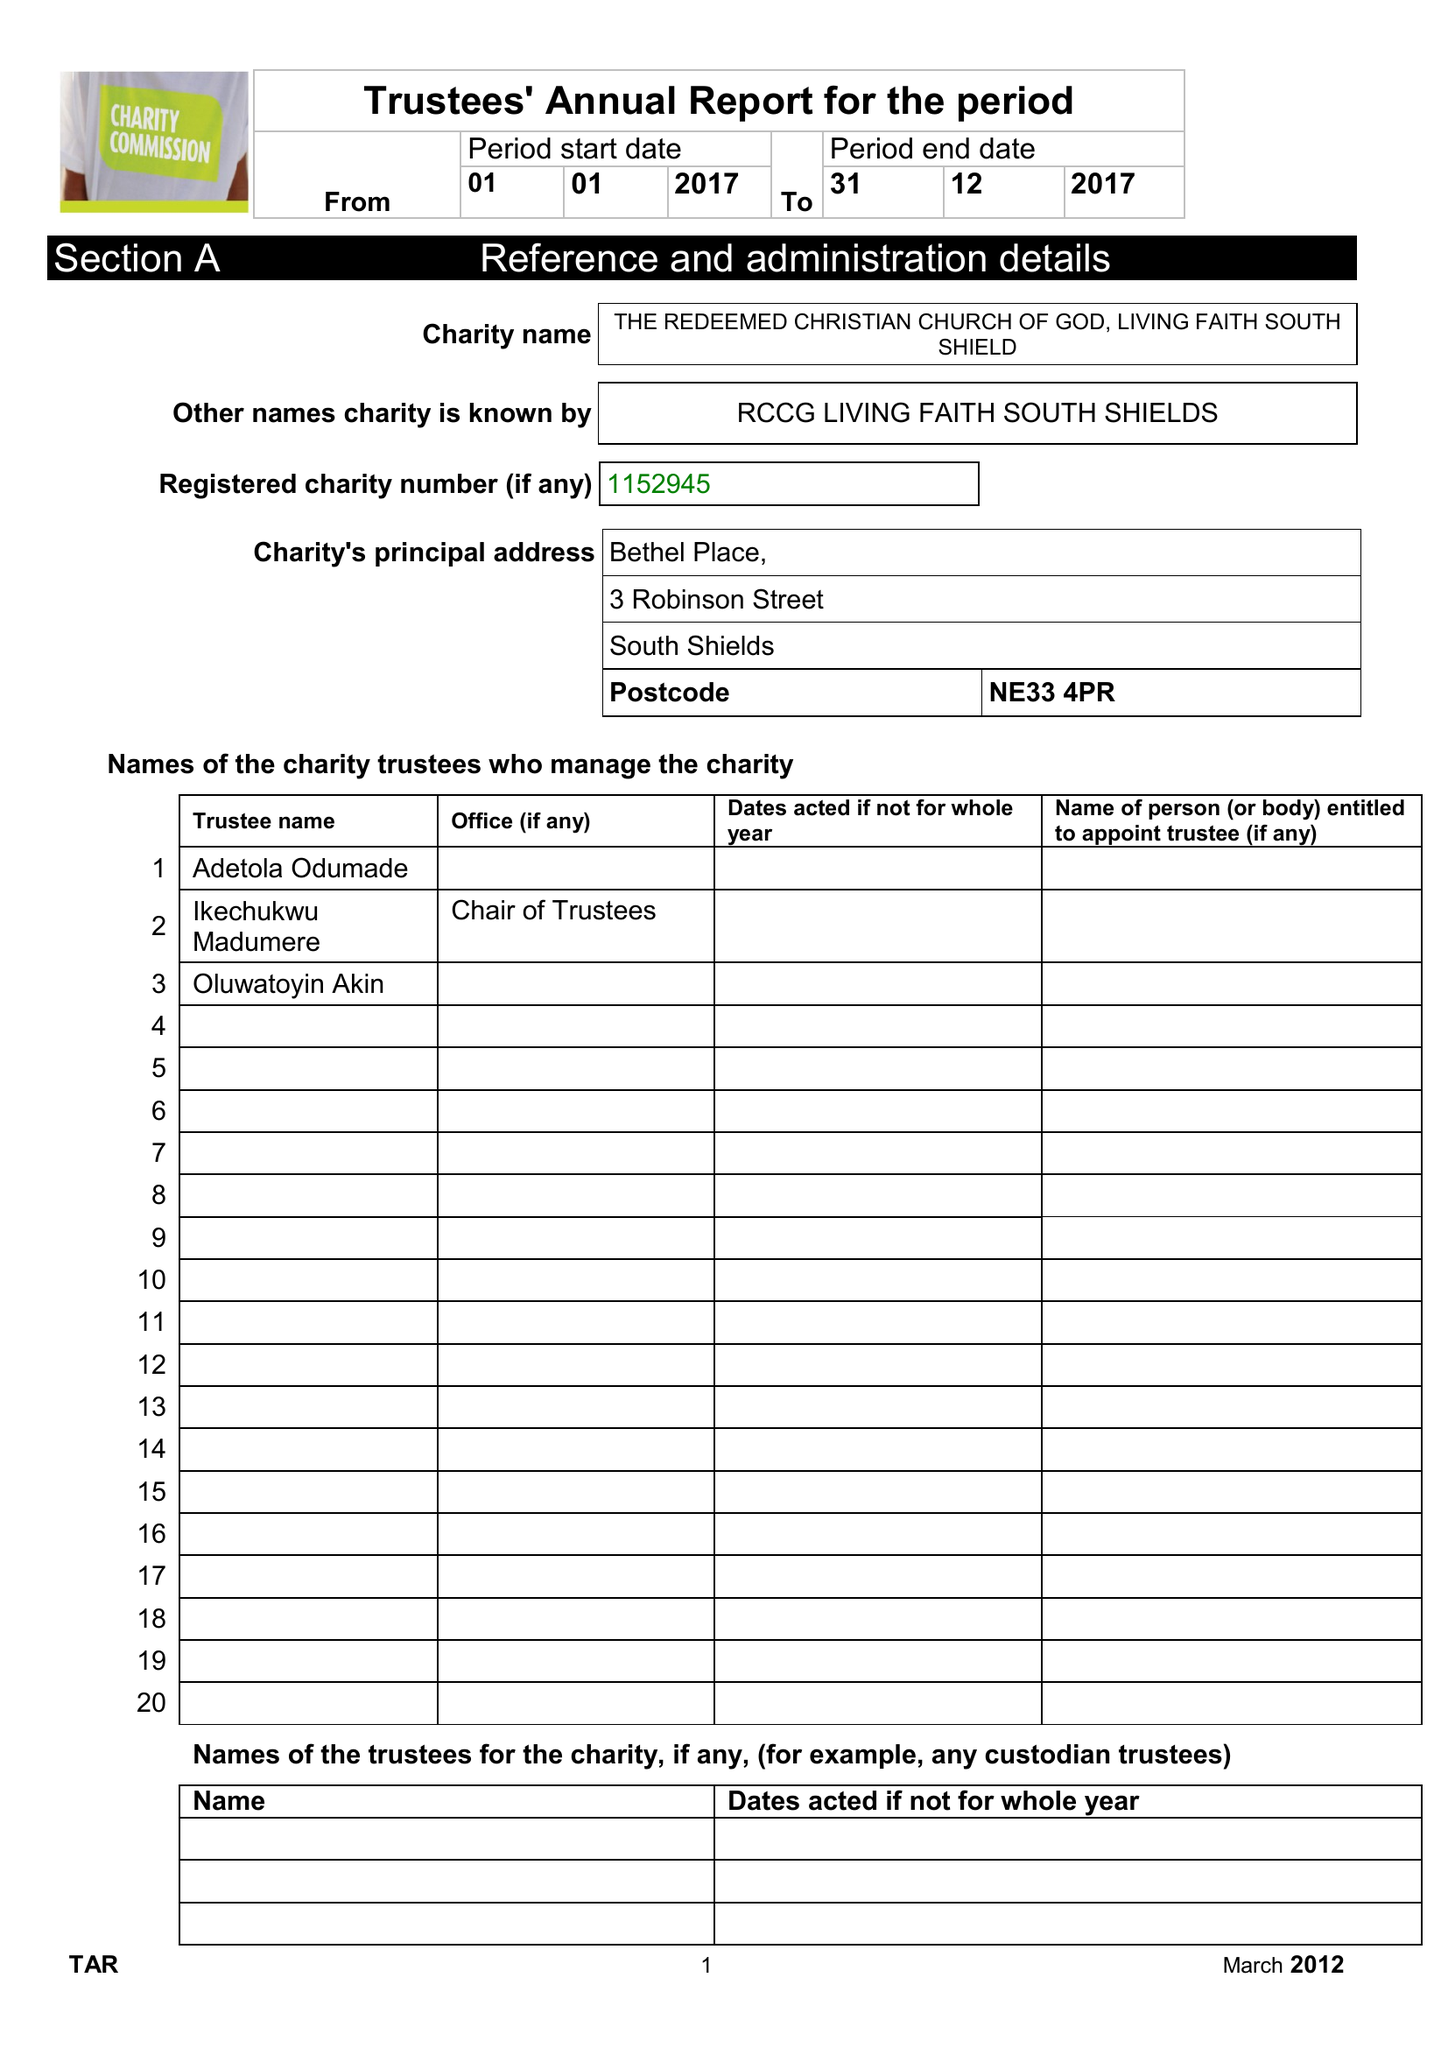What is the value for the address__street_line?
Answer the question using a single word or phrase. 3 ROBINSON STREET 